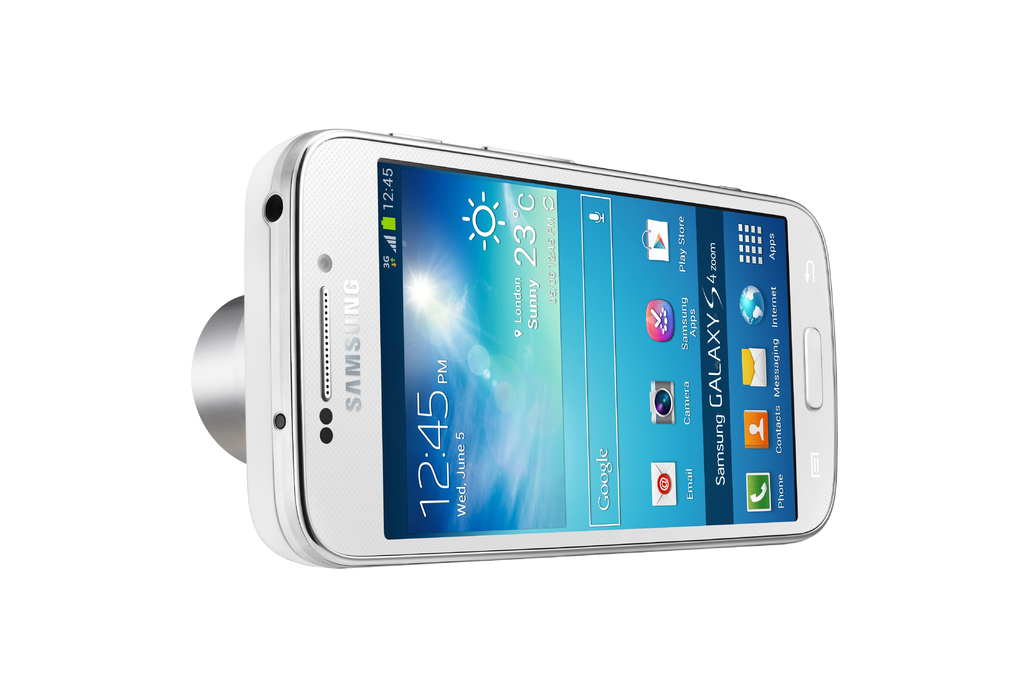What are some of the noticeable features visible on the Samsung Galaxy S4 screen in this image? The Samsung Galaxy S4 screen prominently displays the time as 12:45 PM and the weather as sunny and 23 degrees Celsius, alongside various commonly used apps such as Google, Play Store, Gmail, and Contacts, emphasizing its functionality as an all-in-one digital tool. 